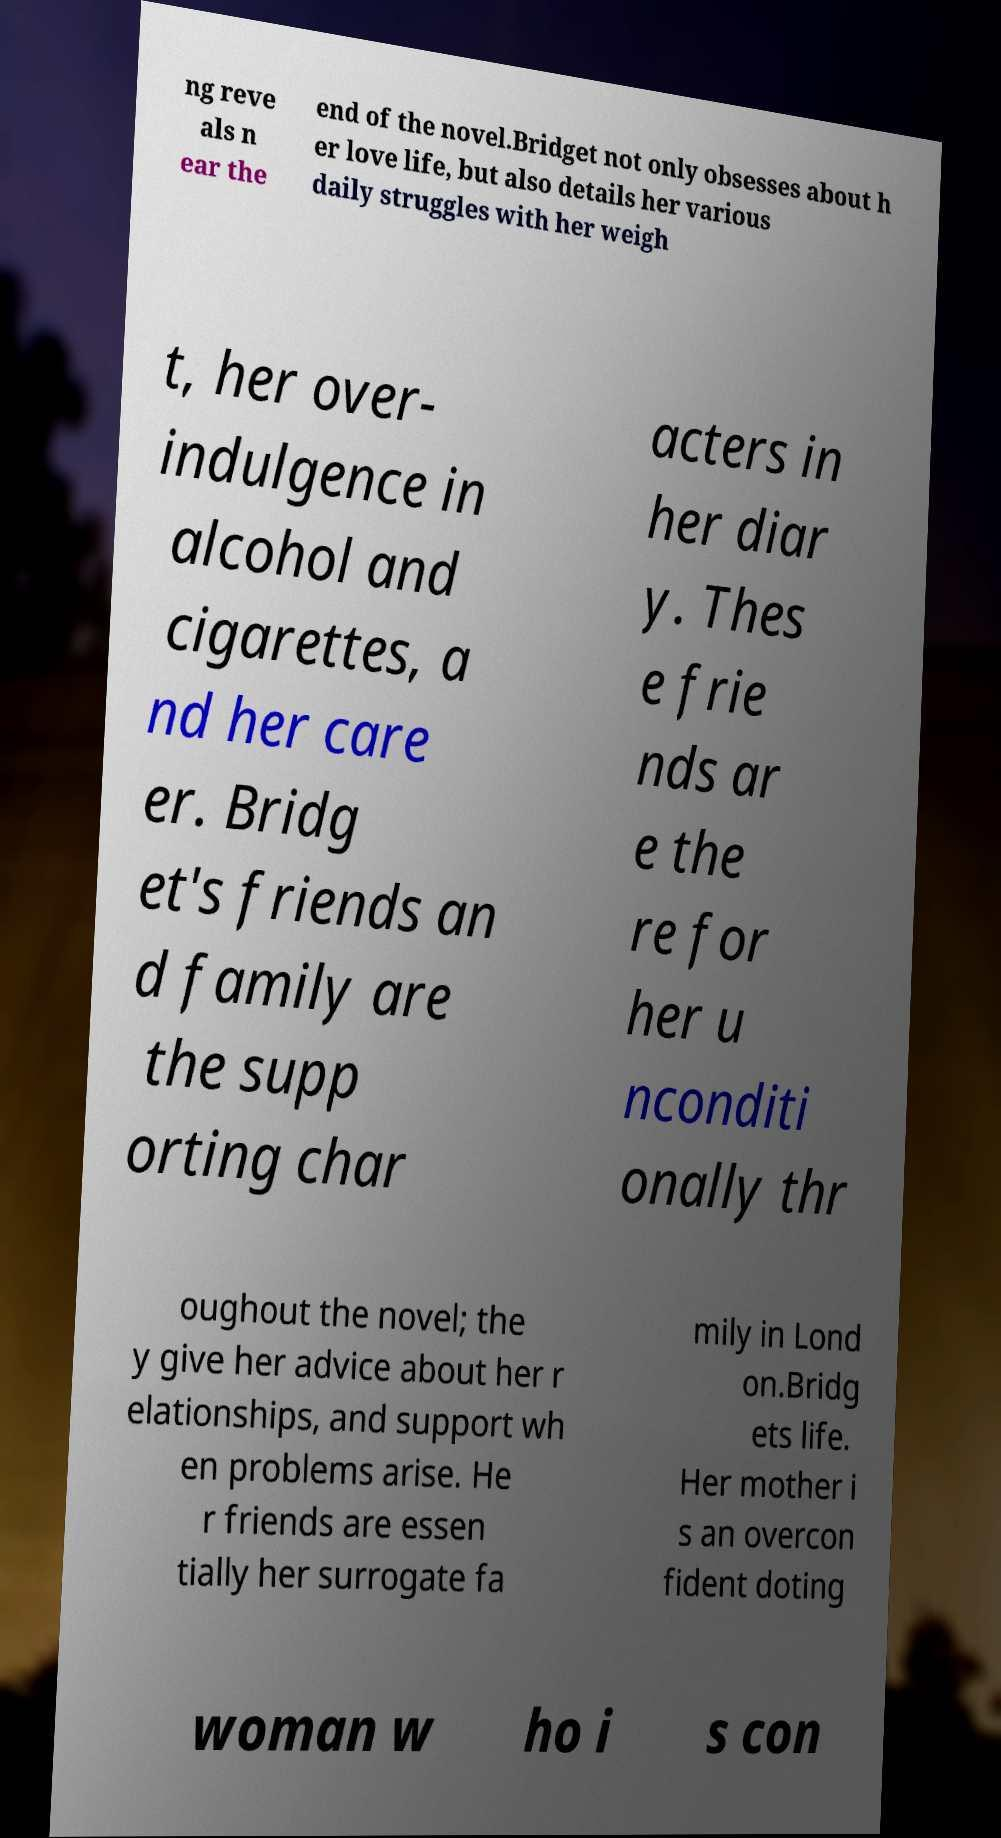Please read and relay the text visible in this image. What does it say? ng reve als n ear the end of the novel.Bridget not only obsesses about h er love life, but also details her various daily struggles with her weigh t, her over- indulgence in alcohol and cigarettes, a nd her care er. Bridg et's friends an d family are the supp orting char acters in her diar y. Thes e frie nds ar e the re for her u nconditi onally thr oughout the novel; the y give her advice about her r elationships, and support wh en problems arise. He r friends are essen tially her surrogate fa mily in Lond on.Bridg ets life. Her mother i s an overcon fident doting woman w ho i s con 